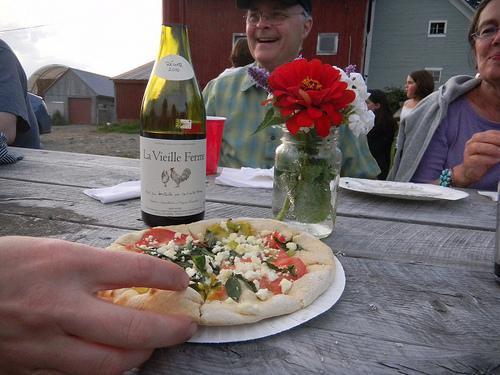How many pizzas are there?
Give a very brief answer. 1. How many pizzas?
Give a very brief answer. 1. How many flowers?
Give a very brief answer. 1. How many pizzas are visible?
Give a very brief answer. 1. 